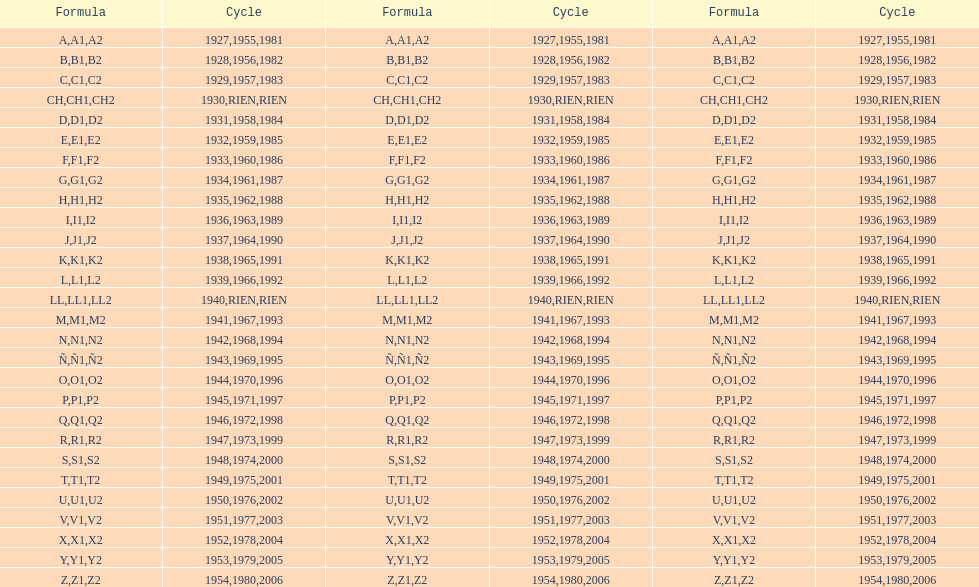Other than 1927 what year did the code start with a? 1955, 1981. 